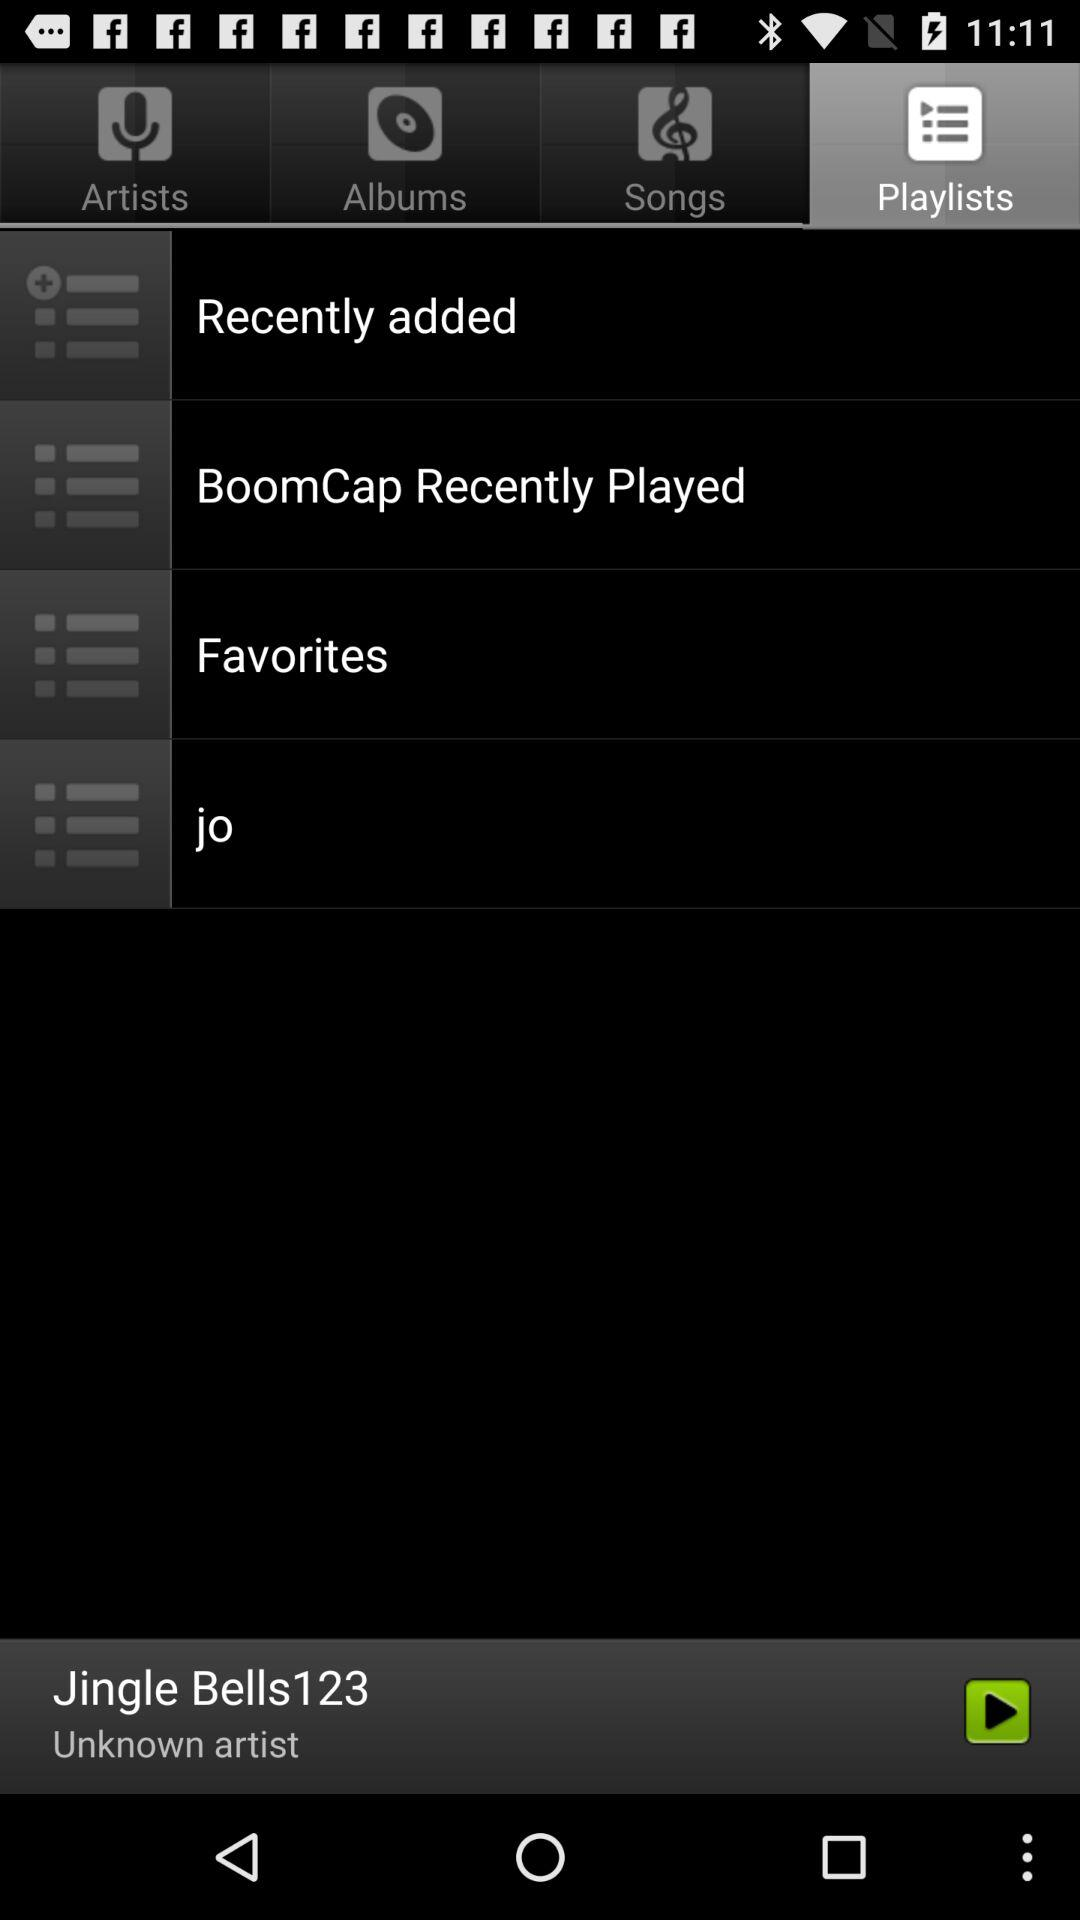What is the selected tab? The selected tab is "Playlists". 